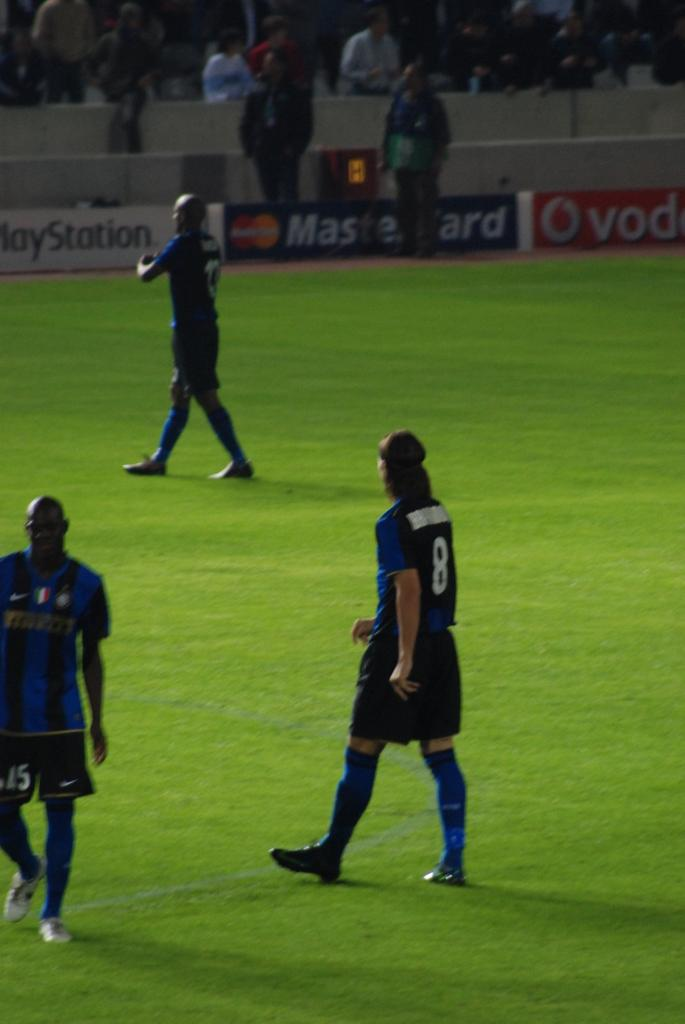<image>
Offer a succinct explanation of the picture presented. Players walking across a sports feild with an advertisement for PlayStation in the background. 